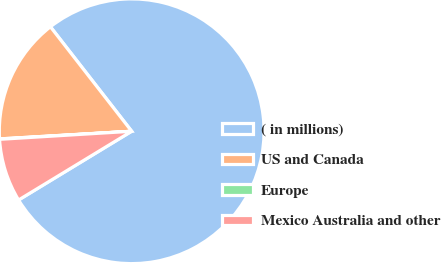Convert chart to OTSL. <chart><loc_0><loc_0><loc_500><loc_500><pie_chart><fcel>( in millions)<fcel>US and Canada<fcel>Europe<fcel>Mexico Australia and other<nl><fcel>76.83%<fcel>15.4%<fcel>0.05%<fcel>7.72%<nl></chart> 